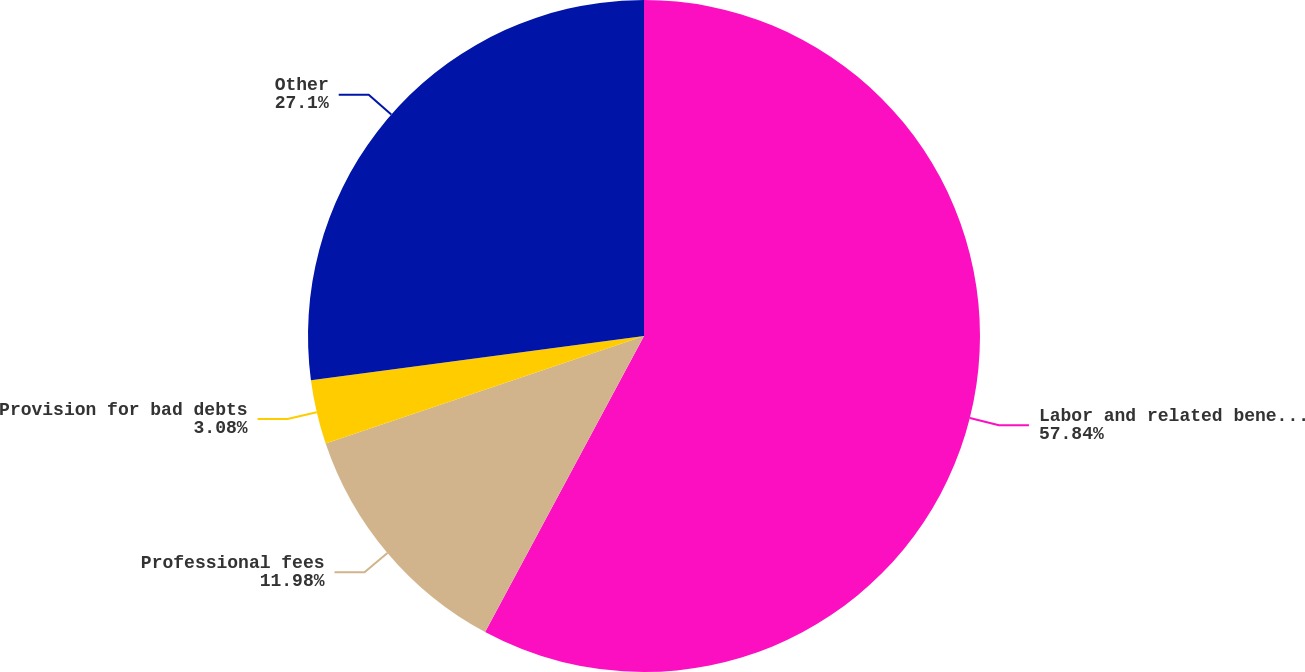Convert chart. <chart><loc_0><loc_0><loc_500><loc_500><pie_chart><fcel>Labor and related benefits<fcel>Professional fees<fcel>Provision for bad debts<fcel>Other<nl><fcel>57.84%<fcel>11.98%<fcel>3.08%<fcel>27.1%<nl></chart> 